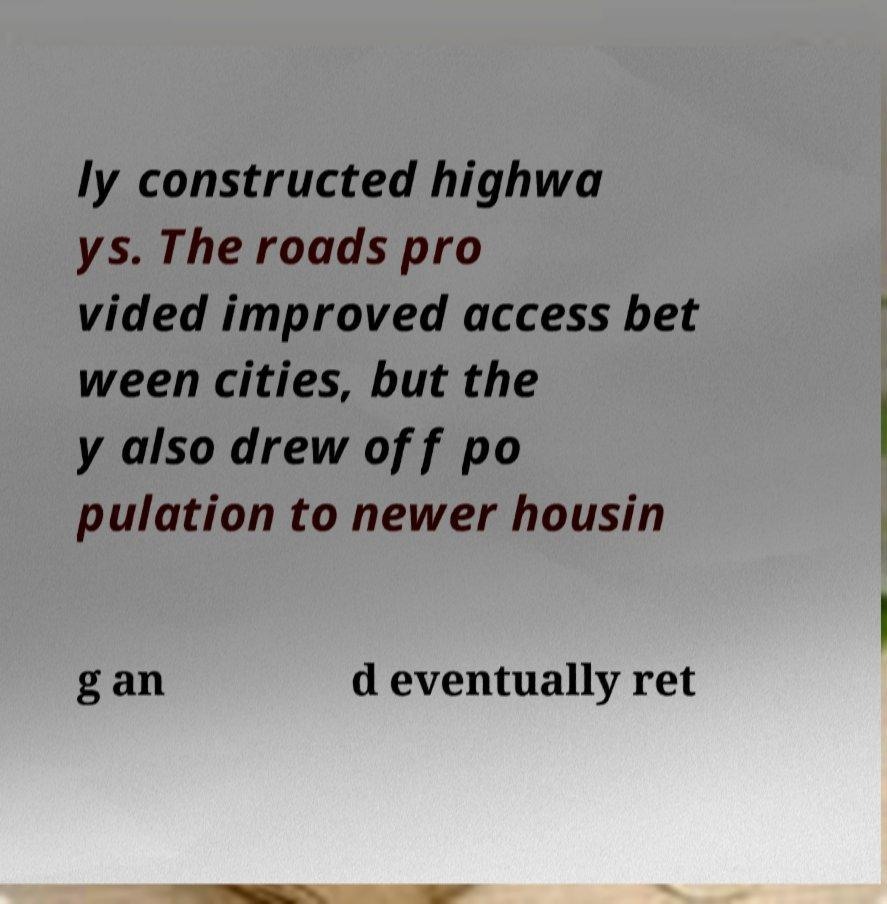Please identify and transcribe the text found in this image. ly constructed highwa ys. The roads pro vided improved access bet ween cities, but the y also drew off po pulation to newer housin g an d eventually ret 